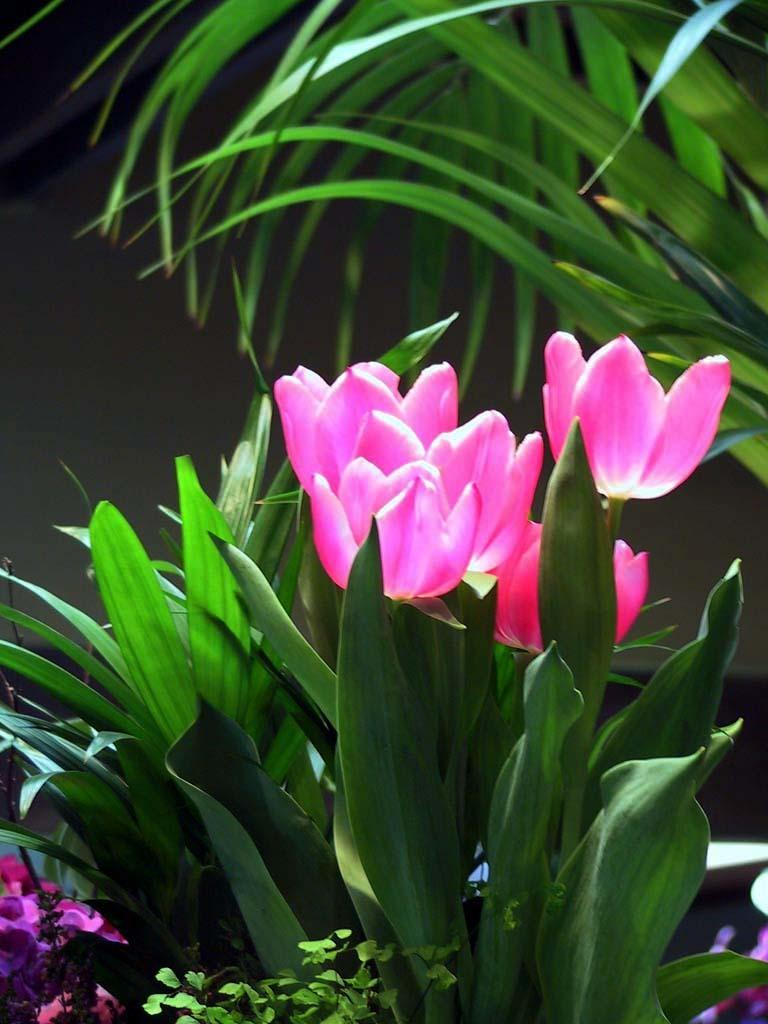What type of living organisms can be seen in the image? Plants and flowers are visible in the image. Can you describe the background of the image? The background of the image is dark. How much money is being exchanged between the flowers in the image? There is no money present in the image, as it features plants and flowers. What type of car can be seen driving through the flowers in the image? There are no cars present in the image; it only contains plants and flowers. 